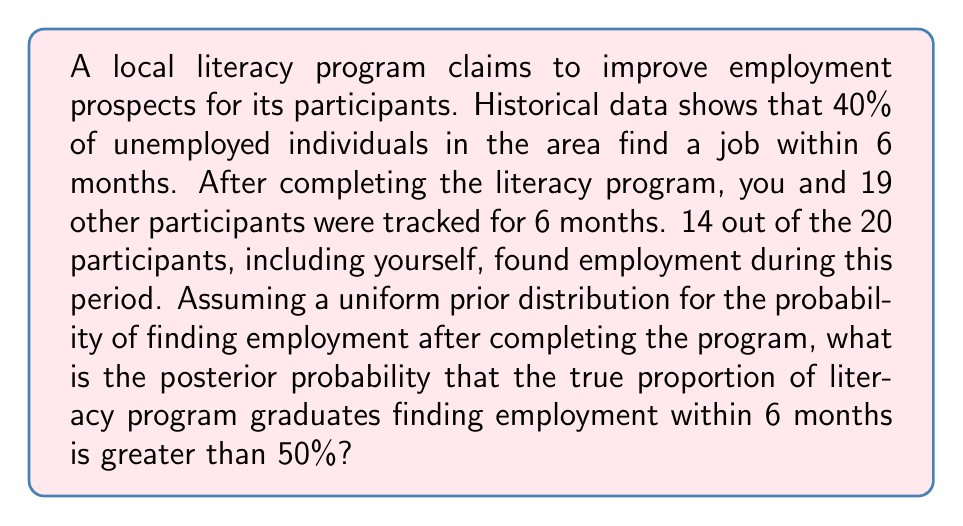Can you solve this math problem? To solve this problem using Bayesian inference, we'll follow these steps:

1) Define our prior distribution:
   We're using a uniform prior, which means Beta(1,1) for a binomial likelihood.

2) Update with the data:
   We observed 14 successes out of 20 trials.
   The posterior distribution is Beta(1+14, 1+20-14) = Beta(15, 7)

3) Calculate the probability that the true proportion is greater than 50%:
   We need to find P(θ > 0.5 | data), where θ is the true proportion.

   This is equivalent to finding the area under the Beta(15, 7) curve from 0.5 to 1.

   We can calculate this using the incomplete beta function:

   $$P(\theta > 0.5 | data) = 1 - I_{0.5}(15, 7)$$

   Where $I_x(a,b)$ is the regularized incomplete beta function.

4) Compute the result:
   Using a statistical software or calculator with beta distribution functions:

   $$1 - I_{0.5}(15, 7) \approx 0.9894$$

Therefore, given the data and our uniform prior, there's approximately a 98.94% posterior probability that the true proportion of literacy program graduates finding employment within 6 months is greater than 50%.

This high probability suggests strong evidence that the literacy program is effective in improving employment prospects, especially compared to the historical rate of 40%.
Answer: 0.9894 (or 98.94%) 